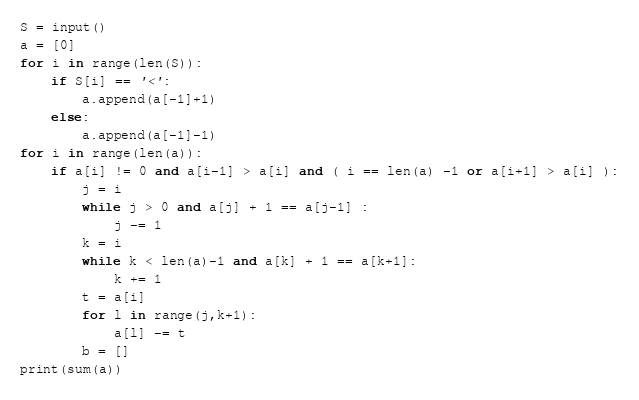<code> <loc_0><loc_0><loc_500><loc_500><_Python_>S = input()
a = [0]
for i in range(len(S)):
    if S[i] == '<':
        a.append(a[-1]+1)
    else:
        a.append(a[-1]-1)
for i in range(len(a)):
    if a[i] != 0 and a[i-1] > a[i] and ( i == len(a) -1 or a[i+1] > a[i] ):
        j = i
        while j > 0 and a[j] + 1 == a[j-1] :
            j -= 1
        k = i
        while k < len(a)-1 and a[k] + 1 == a[k+1]:
            k += 1
        t = a[i]
        for l in range(j,k+1):
            a[l] -= t
        b = []
print(sum(a))
</code> 